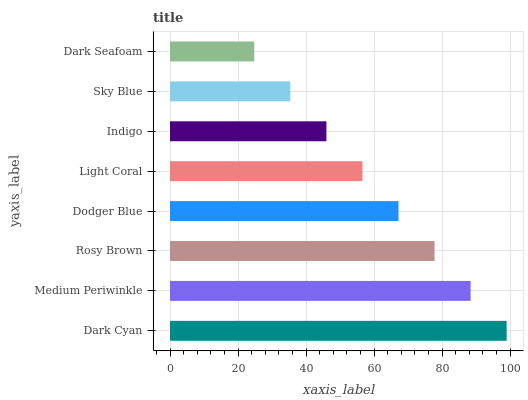Is Dark Seafoam the minimum?
Answer yes or no. Yes. Is Dark Cyan the maximum?
Answer yes or no. Yes. Is Medium Periwinkle the minimum?
Answer yes or no. No. Is Medium Periwinkle the maximum?
Answer yes or no. No. Is Dark Cyan greater than Medium Periwinkle?
Answer yes or no. Yes. Is Medium Periwinkle less than Dark Cyan?
Answer yes or no. Yes. Is Medium Periwinkle greater than Dark Cyan?
Answer yes or no. No. Is Dark Cyan less than Medium Periwinkle?
Answer yes or no. No. Is Dodger Blue the high median?
Answer yes or no. Yes. Is Light Coral the low median?
Answer yes or no. Yes. Is Medium Periwinkle the high median?
Answer yes or no. No. Is Medium Periwinkle the low median?
Answer yes or no. No. 